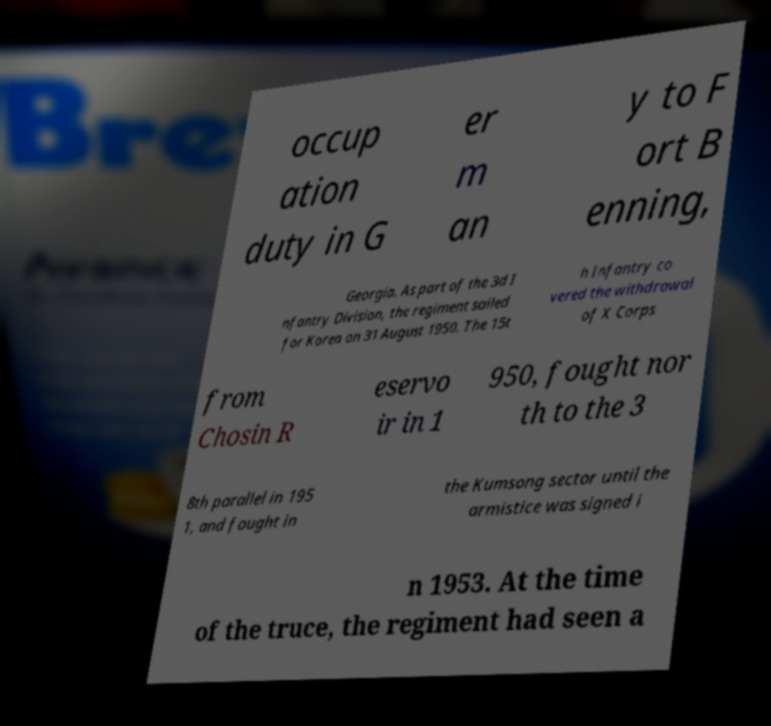Could you extract and type out the text from this image? occup ation duty in G er m an y to F ort B enning, Georgia. As part of the 3d I nfantry Division, the regiment sailed for Korea on 31 August 1950. The 15t h Infantry co vered the withdrawal of X Corps from Chosin R eservo ir in 1 950, fought nor th to the 3 8th parallel in 195 1, and fought in the Kumsong sector until the armistice was signed i n 1953. At the time of the truce, the regiment had seen a 